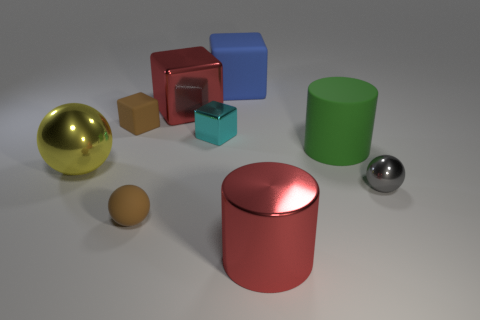Subtract all brown matte spheres. How many spheres are left? 2 Subtract all cyan cubes. How many cubes are left? 3 Subtract 1 blocks. How many blocks are left? 3 Subtract all cylinders. How many objects are left? 7 Subtract 1 green cylinders. How many objects are left? 8 Subtract all gray cubes. Subtract all purple balls. How many cubes are left? 4 Subtract all big red things. Subtract all yellow things. How many objects are left? 6 Add 1 large blocks. How many large blocks are left? 3 Add 4 big shiny cylinders. How many big shiny cylinders exist? 5 